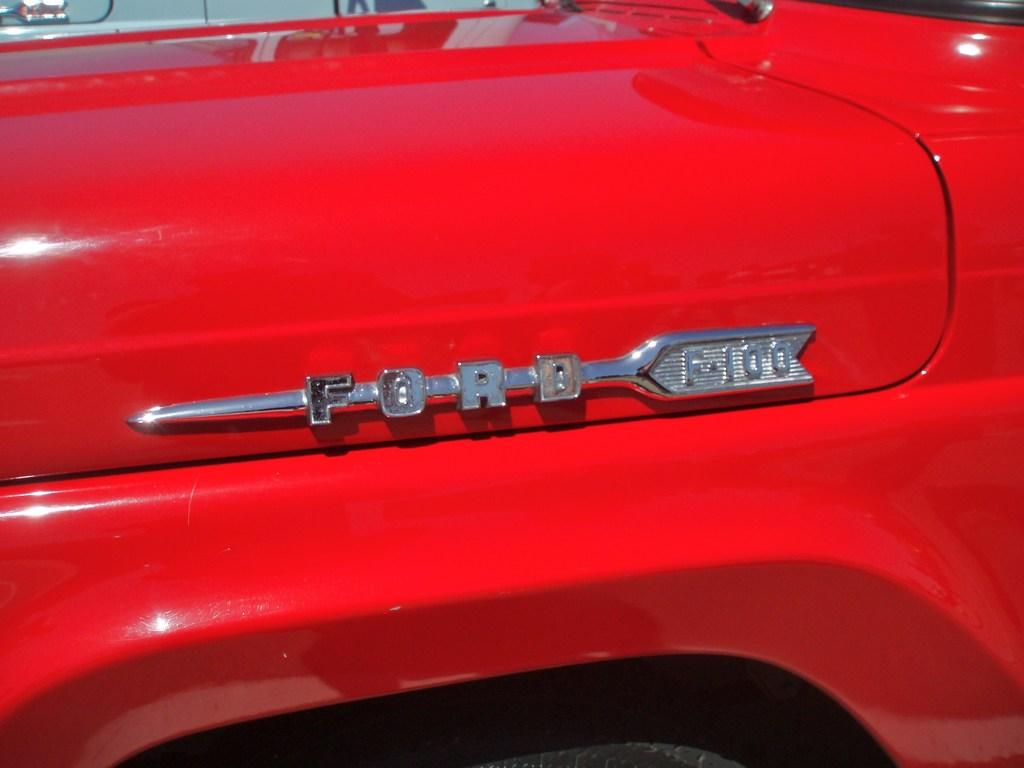What is the main subject of the image? The main subject of the image is a car. What color is the car in the image? The car is red in color. Can you describe any specific features of the car in the image? There is a car logo visible in the middle of the image. What type of steam is coming out of the car's exhaust in the image? There is no steam coming out of the car's exhaust in the image, as it is a zoomed-in view of the car and does not show the exhaust. 